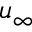Convert formula to latex. <formula><loc_0><loc_0><loc_500><loc_500>u _ { \infty }</formula> 